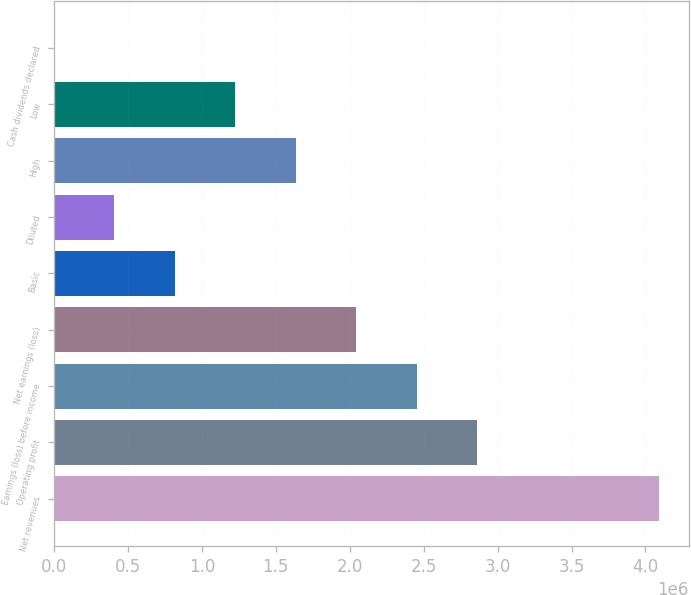<chart> <loc_0><loc_0><loc_500><loc_500><bar_chart><fcel>Net revenues<fcel>Operating profit<fcel>Earnings (loss) before income<fcel>Net earnings (loss)<fcel>Basic<fcel>Diluted<fcel>High<fcel>Low<fcel>Cash dividends declared<nl><fcel>4.08898e+06<fcel>2.86229e+06<fcel>2.45339e+06<fcel>2.04449e+06<fcel>817798<fcel>408900<fcel>1.63559e+06<fcel>1.2267e+06<fcel>1.44<nl></chart> 